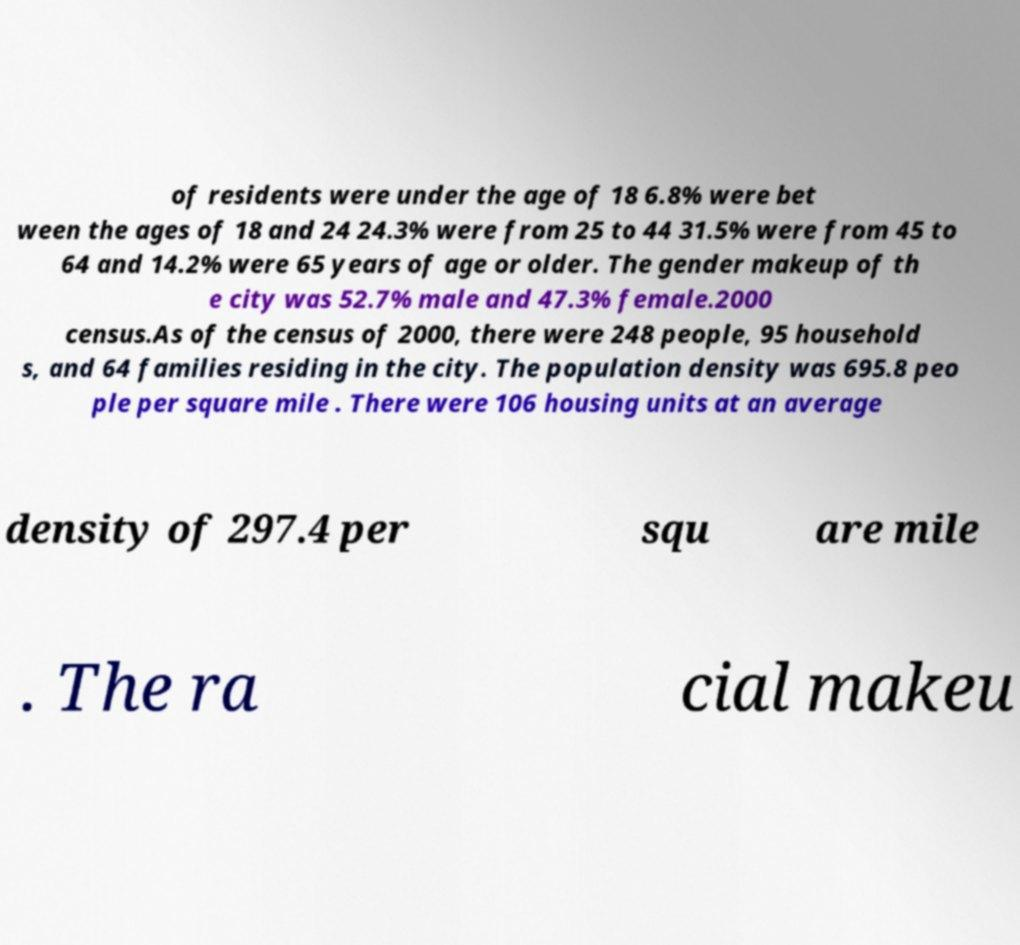Could you extract and type out the text from this image? of residents were under the age of 18 6.8% were bet ween the ages of 18 and 24 24.3% were from 25 to 44 31.5% were from 45 to 64 and 14.2% were 65 years of age or older. The gender makeup of th e city was 52.7% male and 47.3% female.2000 census.As of the census of 2000, there were 248 people, 95 household s, and 64 families residing in the city. The population density was 695.8 peo ple per square mile . There were 106 housing units at an average density of 297.4 per squ are mile . The ra cial makeu 